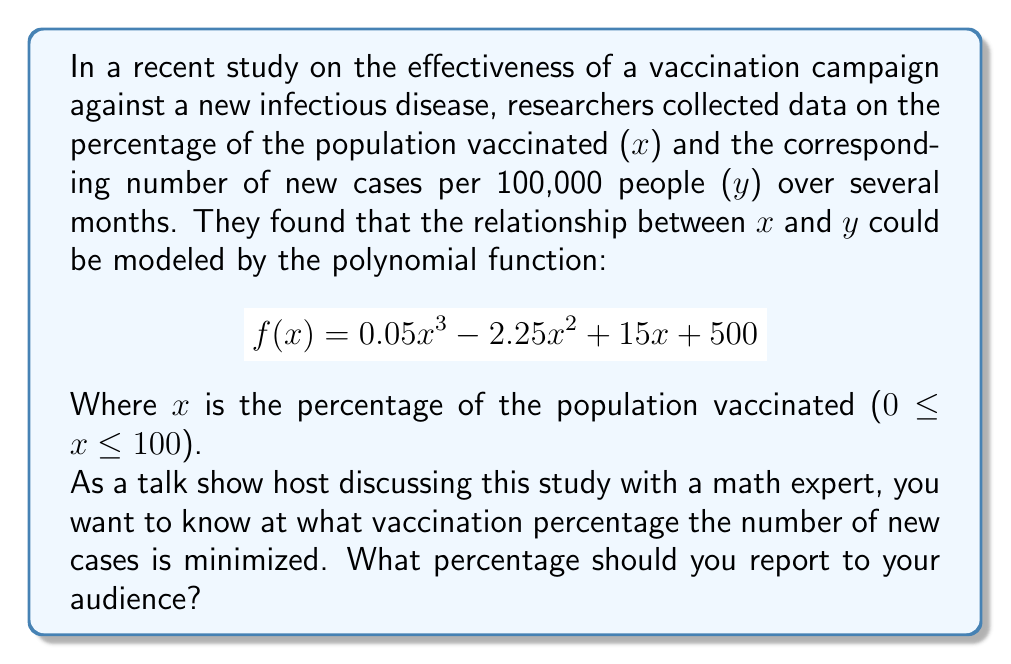Can you solve this math problem? To find the minimum point of the polynomial function, we need to follow these steps:

1. Find the derivative of the function:
   $$ f'(x) = 0.15x^2 - 4.5x + 15 $$

2. Set the derivative equal to zero and solve for x:
   $$ 0.15x^2 - 4.5x + 15 = 0 $$

3. This is a quadratic equation. We can solve it using the quadratic formula:
   $$ x = \frac{-b \pm \sqrt{b^2 - 4ac}}{2a} $$
   Where $a = 0.15$, $b = -4.5$, and $c = 15$

4. Plugging in the values:
   $$ x = \frac{4.5 \pm \sqrt{(-4.5)^2 - 4(0.15)(15)}}{2(0.15)} $$

5. Simplifying:
   $$ x = \frac{4.5 \pm \sqrt{20.25 - 9}}{0.3} = \frac{4.5 \pm \sqrt{11.25}}{0.3} $$

6. Calculating:
   $$ x \approx 26.79 \text{ or } 3.21 $$

7. Since we're looking for a percentage between 0 and 100, we choose 26.79.

8. To confirm this is a minimum (not a maximum), we can check the second derivative:
   $$ f''(x) = 0.3x - 4.5 $$
   At $x = 26.79$, $f''(26.79) \approx 3.54 > 0$, confirming it's a minimum.

Therefore, the number of new cases is minimized when approximately 26.79% of the population is vaccinated.
Answer: 26.79% 